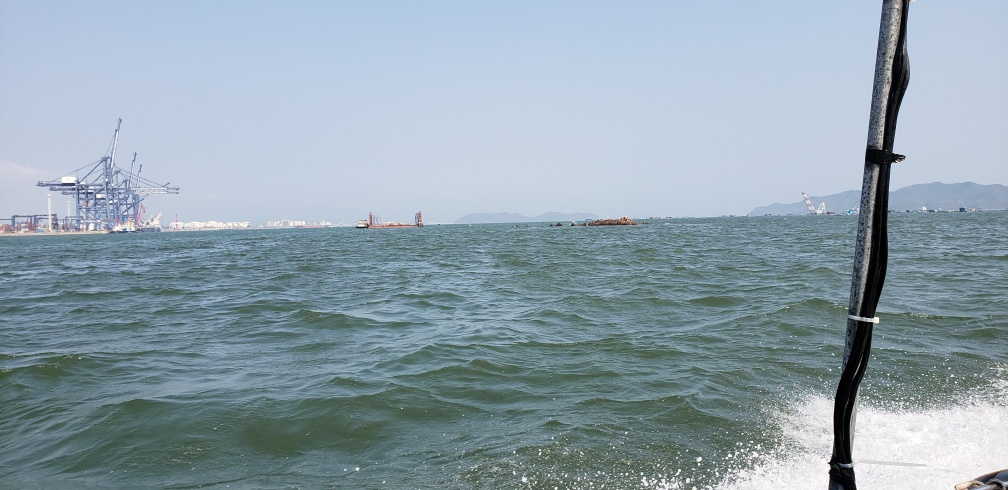Can you tell me more about the body of water captured in this image? The water in the image is a vast expanse, indicative of a sea or ocean. Its choppy surface reflects the light, suggesting some wind activity and the presence of those swellings is typical of large, open bodies of water. 